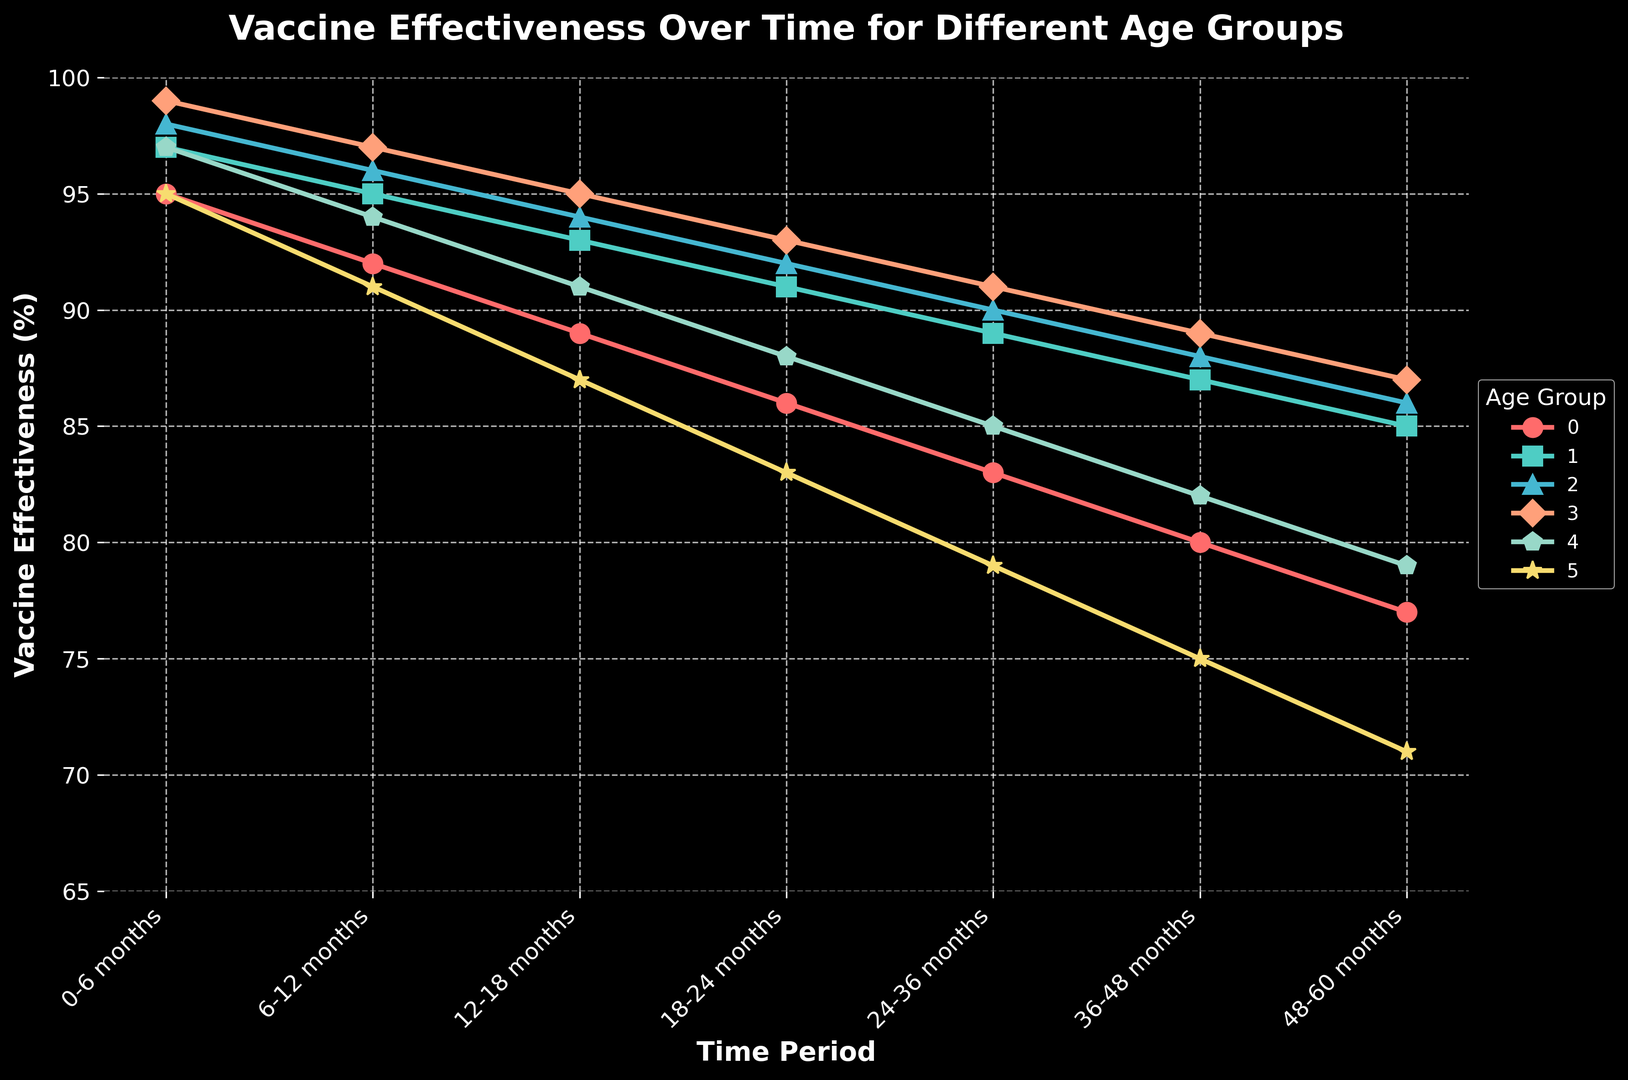What is the effectiveness rate for the 5-11 years age group at 24-36 months? Observe the 5-11 years age group line and locate the data point at the 24-36 months mark.
Answer: 89% Which age group has the steepest decline in effectiveness rate from 24-36 months to 65+ months? Compare the slopes of the effectiveness rate lines between 24-36 months and 65+ months. The steepest decline indicates the largest negative change. The 65+ years age group shows the steepest decline.
Answer: 65+ years What is the difference in effectiveness rate between the 0-4 years and 18-49 years age groups at the 0-6 months mark? Subtract the effectiveness rate of the 0-4 years age group from that of the 18-49 years age group at the respective mark. 99% (18-49 years) - 95% (0-4 years) = 4%.
Answer: 4% Identify the age group with the highest initial vaccine effectiveness at 0-6 months. Locate and compare the effectiveness rates at the 0-6 months mark for all age groups. The 18-49 years age group has the highest initial effectiveness.
Answer: 18-49 years Which age group maintains an effectiveness rate above 85% for the longest time period? Determine until which time point each age group maintains an effectiveness rate above 85%. The 18-49 years age group maintains it above 85% up to the 48-60 months mark.
Answer: 18-49 years Compare the effectiveness rates of the 12-17 years and 50-64 years age groups at 36-48 months. Find the effectiveness rates at the 36-48 months mark for both age groups and compare their values. 88% (12-17 years) is greater than 82% (50-64 years).
Answer: 12-17 years What is the average effectiveness rate for the 0-4 years age group over all time periods? Sum the effectiveness rates for the 0-4 years age group across all time periods and divide by the number of periods. (95+92+89+86+83+80+77) / 7 ≈ 86%.
Answer: 86% How does the vaccine effectiveness for the 65+ years age group at 48-60 months compare to the 12-17 years age group at the same time? Find and compare the effectiveness rates for both age groups at the 48-60 months mark. The 12-17 years age group (86%) has a higher rate than the 65+ years group (71%).
Answer: 12-17 years Which age group shows the least variance in effectiveness rates over time? Visually inspect and compare the consistency of the effectiveness rates of each age group over the entire period. The 18-49 years age group shows the least variance.
Answer: 18-49 years 